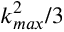Convert formula to latex. <formula><loc_0><loc_0><loc_500><loc_500>k _ { \max } ^ { 2 } / 3</formula> 